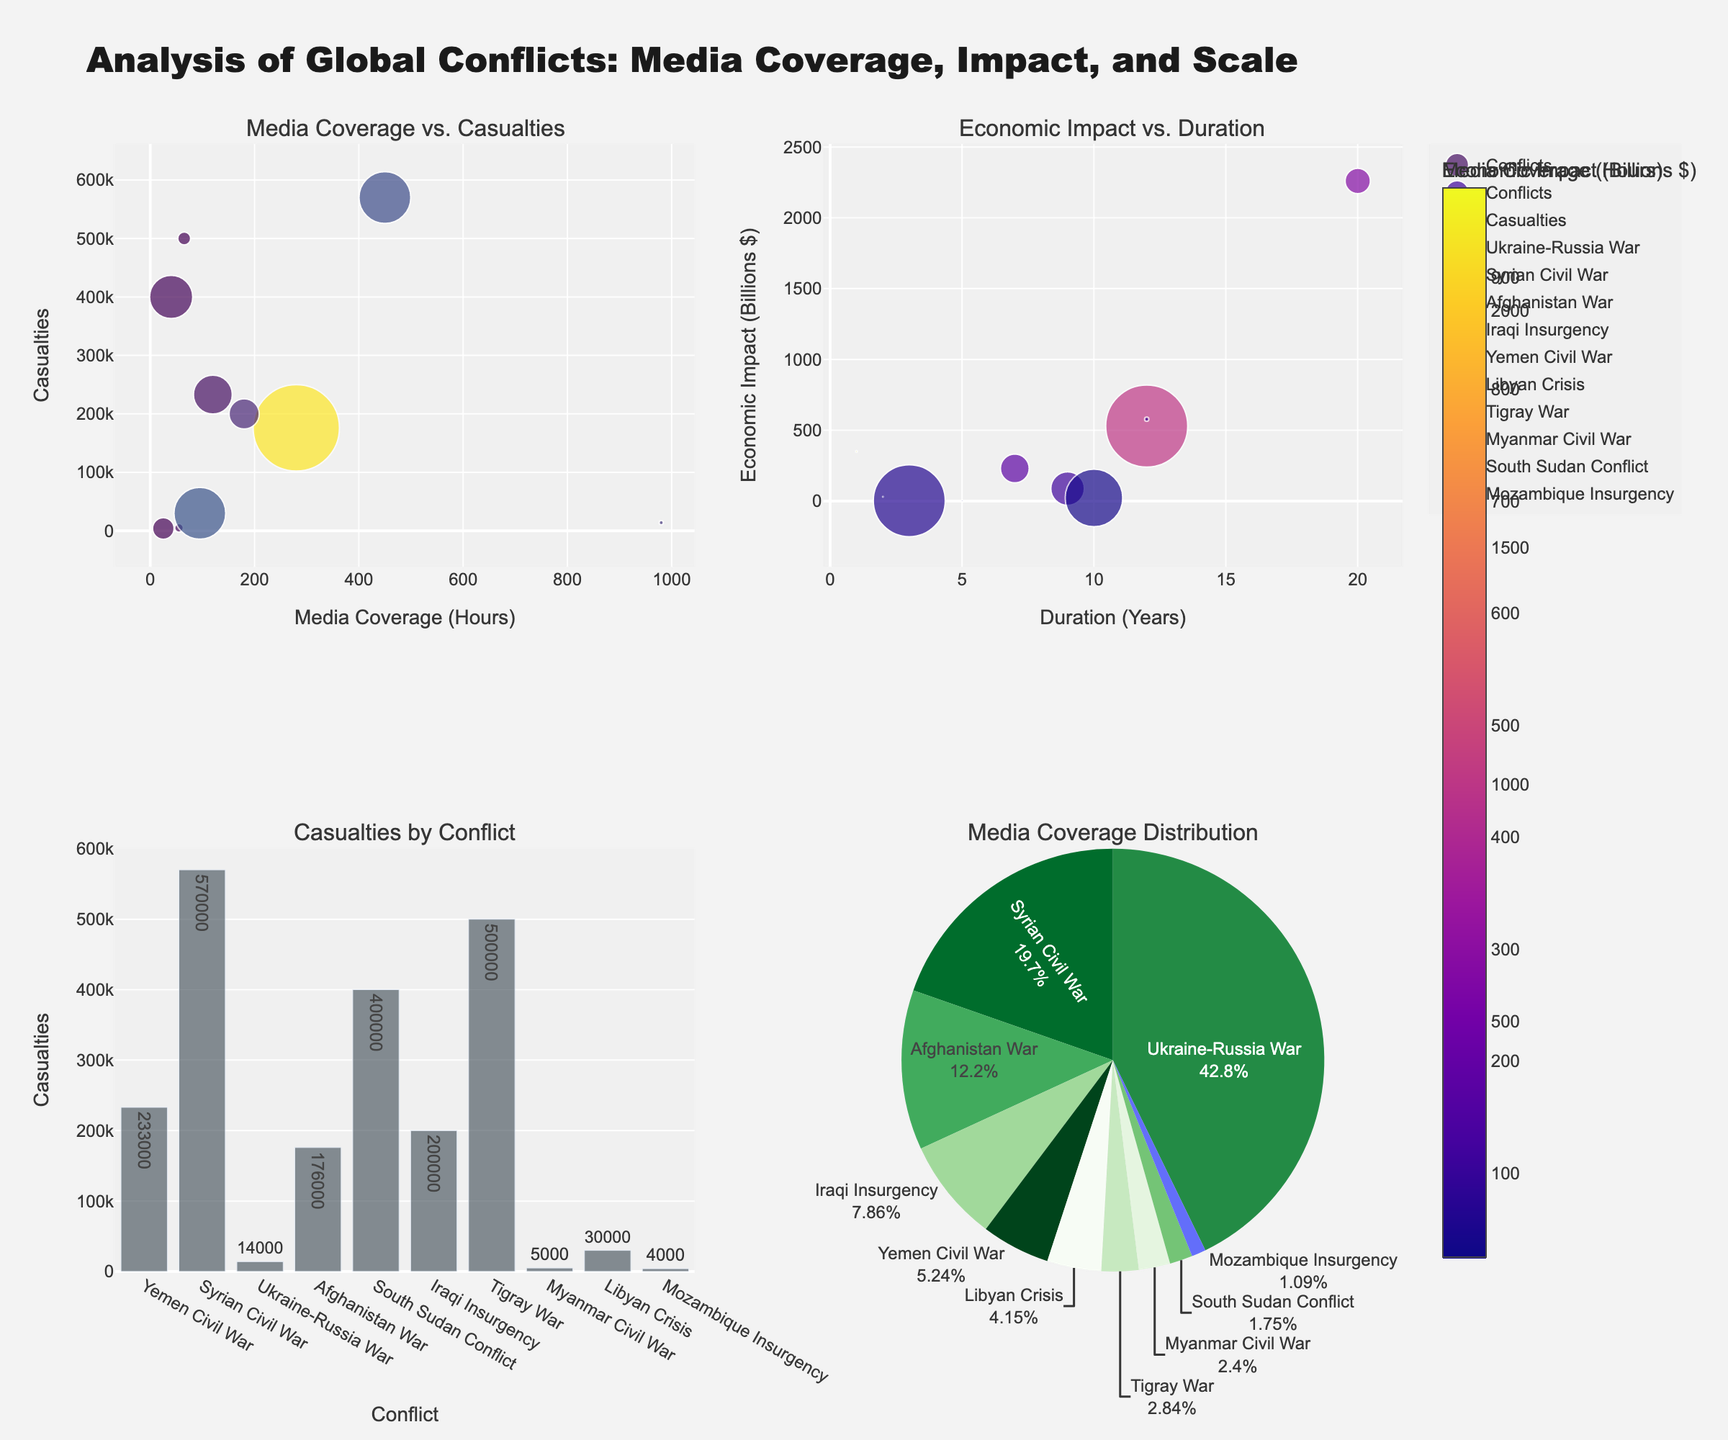Which conflict has the highest number of casualties? The bar chart in the bottom left corner lists casualties by conflict, and the highest bar represents the Syrian Civil War.
Answer: Syrian Civil War What is the economic impact of the conflict in Yemen? In the scatter plot "Economic Impact vs. Duration" in the top right corner, the Yemen conflict is represented by the point labeled "Yemen Civil War" with a vertical position of about 88 billion dollars.
Answer: $88 billion Which conflict has the highest media coverage in hours? The pie chart in the bottom right summarizes media coverage hours, the largest section belongs to the Ukraine-Russia War.
Answer: Ukraine-Russia War How does the duration of the Afghan War compare to the duration of the Ukraine-Russia War? The scatter plot "Economic Impact vs. Duration" shows duration on the x-axis. The Afghan War has a duration point around 20 years, and the Ukraine-Russia War is at 1 year.
Answer: Afghan War is much longer Which conflict has the lowest media coverage in hours? The pie chart in the bottom right shows the percentage contributions of media coverage, and the smallest segment is the Mozambique Insurgency.
Answer: Mozambique Insurgency What is the relationship between casualties and media coverage for the South Sudan conflict? On the scatter plot "Media Coverage vs. Casualties," the South Sudan conflict's point is low on the x-axis (low coverage) and high on the y-axis (high casualties).
Answer: Low media coverage, high casualties How does the economic impact of the Libyan Crisis compare to the economic impact of the Tigray War? The scatter plot "Economic Impact vs. Duration" shows the Libyan Crisis at about 578 billion dollars and the Tigray War at about 2.5 billion dollars.
Answer: Libyan Crisis is much higher What is the color gradient used to indicate in the scatter plot for "Media Coverage vs. Casualties"? The color gradient in the scatter plot for "Media Coverage vs. Casualties" represents the economic impact in billions of dollars, as labeled in the color bar.
Answer: Economic Impact Which conflict experienced the highest number of casualties within the shortest duration? The scatter plot "Media Coverage vs. Casualties" shows the shortest duration as indicated by smaller marker sizes, with the highest casualties being the Tigray War (around 3 years).
Answer: Tigray War What is the media coverage in hours for the Syrian Civil War? The pie chart and scatter plot (Media Coverage vs. Casualties) show the Syrian Civil War with media coverage of about 450 hours.
Answer: 450 hours 